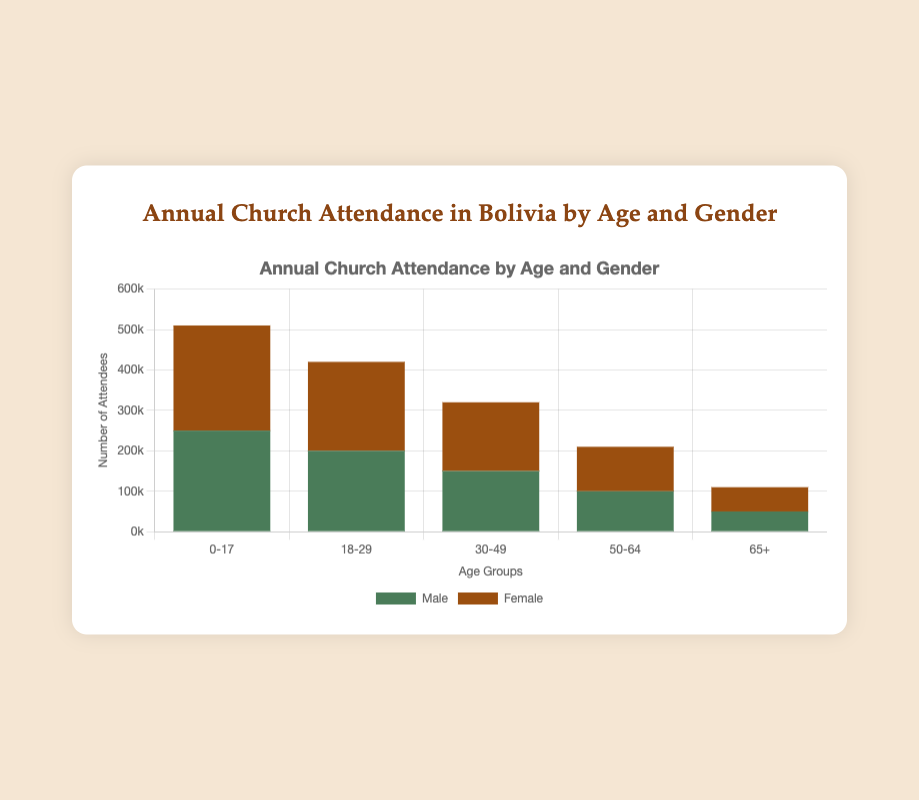Which age group has the highest number of female attendees? Observing the heights of the bars corresponding to Female attendees across the different age groups: 0-17, 18-29, 30-49, 50-64, and 65+, the highest is for the age group 0-17.
Answer: 0-17 What is the total number of church attendees for the 18-29 age group? Sum the number of Male and Female attendees for the 18-29 age group: 200,000 (Male) + 220,000 (Female) = 420,000.
Answer: 420,000 By how much do female attendees outnumber male attendees in the 50-64 age group? The number of female attendees in the 50-64 age group is 110,000 and male attendees are 100,000. Subtracting these gives: 110,000 - 100,000 = 10,000.
Answer: 10,000 Which gender has a higher attendance in the 65+ age group? Comparing the heights of the Male and Female bars for the 65+ age group, the Female bar is taller.
Answer: Female What is the percentage of Male attendees in the 0-17 age group out of the total attendees in that group? The total number of attendees in the 0-17 age group is 250,000 (Male) + 260,000 (Female) = 510,000. The percentage of Male attendees is (250,000 / 510,000) * 100 ≈ 49.02%.
Answer: 49.02% Which age group has the least total number of attendees? Summing the Male and Female attendees for each age group: 0-17 (510,000), 18-29 (420,000), 30-49 (320,000), 50-64 (210,000), 65+ (110,000). The least is for the age group 65+.
Answer: 65+ Compare the total attendance of the 30-49 age group to the 50-64 age group. Which is higher? The total attendees for the 30-49 group is 320,000 and for the 50-64 group is 210,000. Therefore, the 30-49 group has higher attendance.
Answer: 30-49 What is the combined total number of male attendees across all age groups? Summing the male attendees: 250,000 (0-17) + 200,000 (18-29) + 150,000 (30-49) + 100,000 (50-64) + 50,000 (65+) = 750,000.
Answer: 750,000 What proportion of the total attendees in the 30-49 age group are female? The total number of attendees in the 30-49 group is 150,000 (Male) + 170,000 (Female) = 320,000. The proportion of Female attendees is 170,000 / 320,000 = 0.53125, or 53.13%.
Answer: 53.13% What is the difference in the number of attendees between the largest and smallest age groups? The largest total attendance is in the 0-17 age group with 510,000, and the smallest is in the 65+ age group with 110,000. The difference is 510,000 - 110,000 = 400,000.
Answer: 400,000 